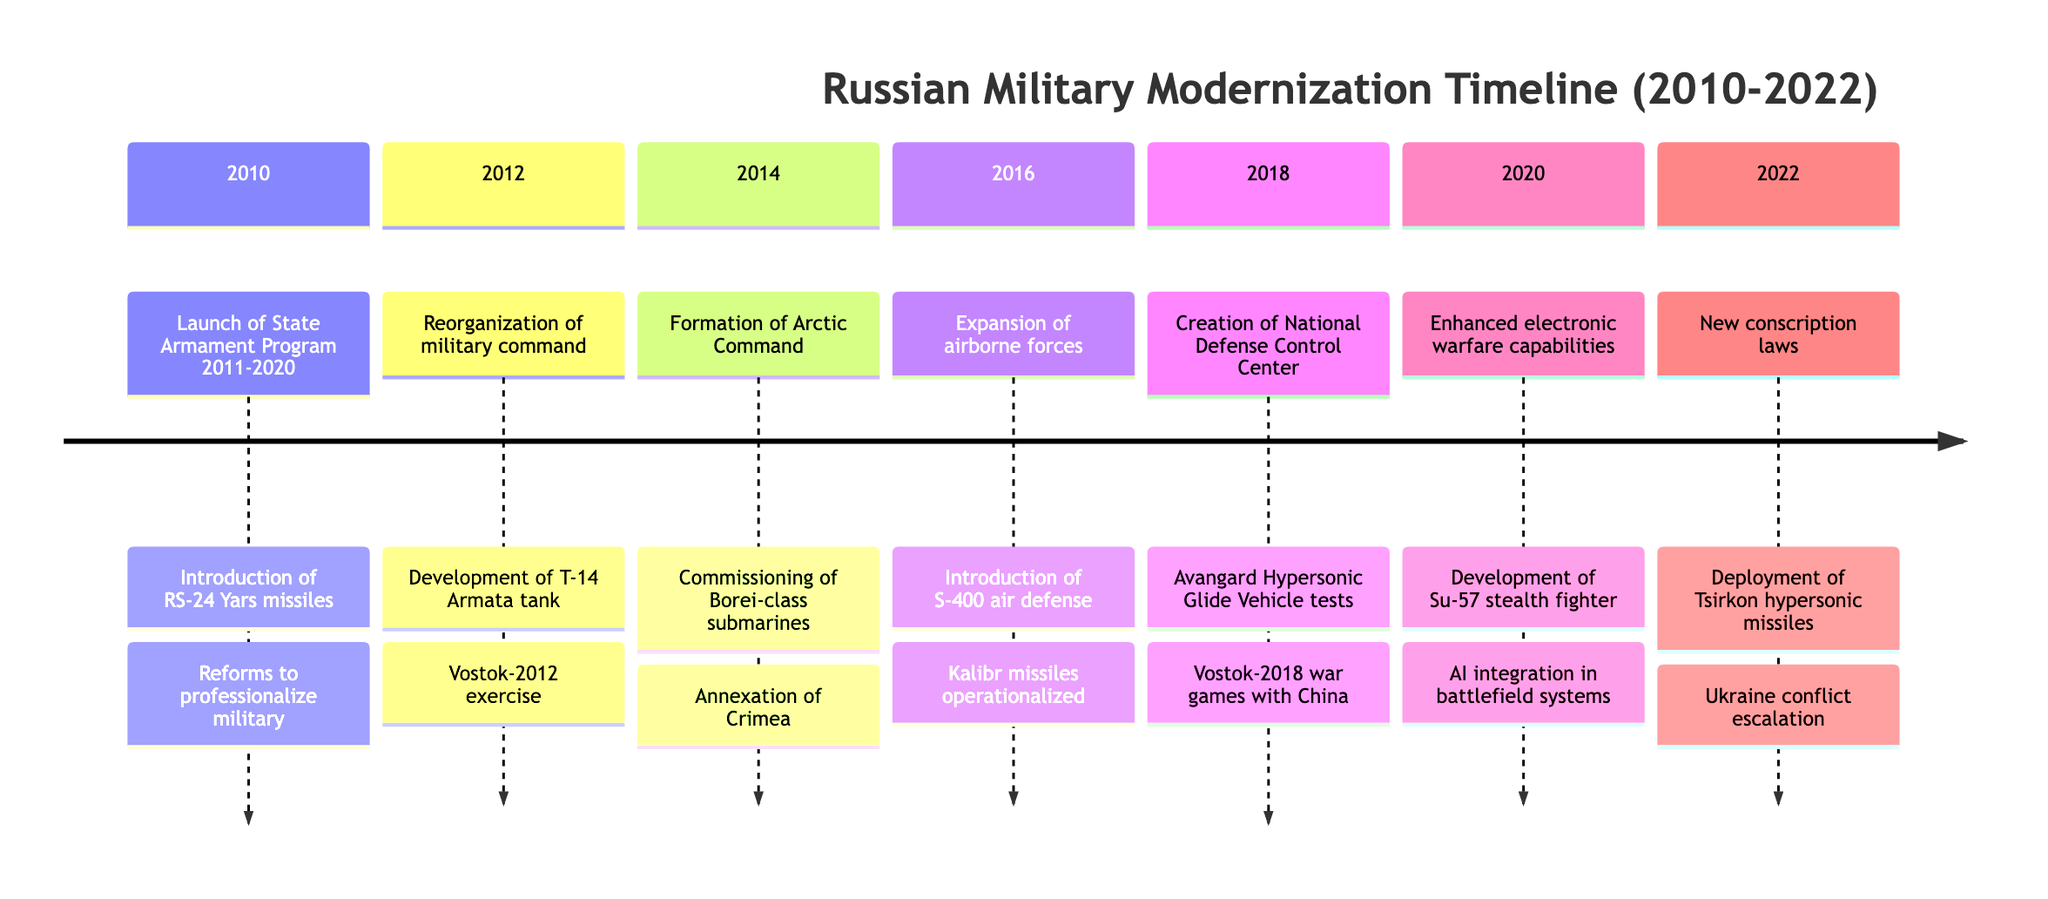What reforms were launched in 2010? In 2010, the timeline indicates that the reforms launched included the "State Armament Program 2011-2020," which had a budget of $700 billion. This is directly mentioned in the corresponding section for 2010.
Answer: State Armament Program 2011-2020 What notable event occurred in 2014? According to the diagram, the notable events listed for 2014 include both the "Annexation of Crimea" and the "Increase in NATO-Russia tensions." Focusing on notable events mentioned, the annexation is a key highlight.
Answer: Annexation of Crimea Which technological advancement was developed in 2012? In 2012, the timeline highlights the development of the "T-14 Armata main battle tank." This advancement is stated as a significant technological milestone for that year.
Answer: T-14 Armata main battle tank What was the strategic objective for Russia in 2016? The strategic objectives listed for 2016 include "Enhance strategic reach" and "Deter NATO advances." These objectives summarize Russia's military strategy during that year as indicated in the timeline.
Answer: Enhance strategic reach How many years did the State Armament Program cover? The State Armament Program is specified in 2010 and is stated to cover from 2011 to 2020, making it a total of 10 years in scope.
Answer: 10 years Which new military feature was introduced in 2020? The timeline indicates that in 2020, there were enhancements in "electronic warfare capabilities," which represents a significant military feature introduced during that year.
Answer: Electronic warfare capabilities What was a significant military event in 2018? The timeline for 2018 mentions the "Launch of Vostok-2018 war games, involving China" as a key significant military event for that year, showcasing military cooperation.
Answer: Launch of Vostok-2018 war games What capacity did the Borei-class submarines contribute to in 2014? The commissioning of "Borei-class nuclear submarines" in 2014 indicates a significant enhancement of naval capabilities, particularly in terms of strategic nuclear deterrence.
Answer: Naval capabilities What were the strategic objectives highlighted in 2022? In 2022, the strategic objectives list includes "Demonstrate military prowess and strategic opportunities" and "Counter perceived NATO encroachment," reflecting Russia's response to contemporary threats.
Answer: Demonstrate military prowess and strategic opportunities 